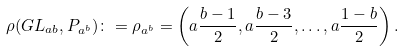Convert formula to latex. <formula><loc_0><loc_0><loc_500><loc_500>\rho ( G L _ { a b } , P _ { a ^ { b } } ) \colon = \rho _ { a ^ { b } } = \left ( a \frac { b - 1 } { 2 } , a \frac { b - 3 } { 2 } , \dots , a \frac { 1 - b } { 2 } \right ) .</formula> 